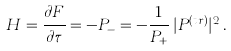Convert formula to latex. <formula><loc_0><loc_0><loc_500><loc_500>H = \frac { \partial F } { \partial \tau } = - P _ { - } = - \frac { 1 } { P _ { + } } \, | P ^ { ( t r ) } | ^ { 2 } \, .</formula> 